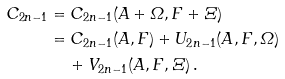<formula> <loc_0><loc_0><loc_500><loc_500>C _ { 2 n - 1 } & = C _ { 2 n - 1 } ( A + \varOmega , F + \varXi ) \\ & = C _ { 2 n - 1 } ( A , F ) + U _ { 2 n - 1 } ( A , F , \varOmega ) \\ & \quad \, + V _ { 2 n - 1 } ( A , F , \varXi ) \, .</formula> 